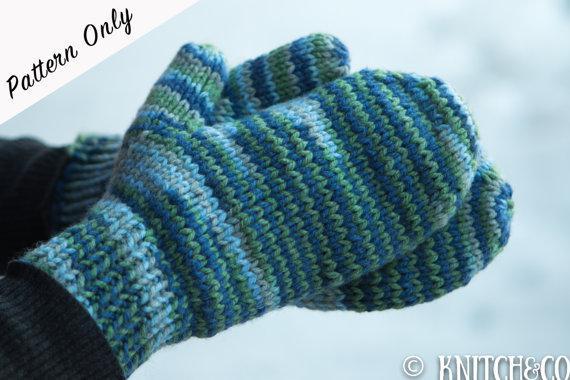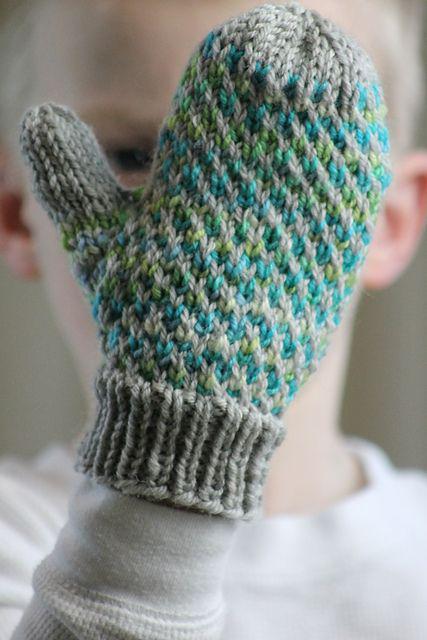The first image is the image on the left, the second image is the image on the right. Examine the images to the left and right. Is the description "An image includes a hand wearing a solid-blue fingerless mitten." accurate? Answer yes or no. No. The first image is the image on the left, the second image is the image on the right. Given the left and right images, does the statement "In one of the images there is a single mitten worn on an empty hand." hold true? Answer yes or no. Yes. 